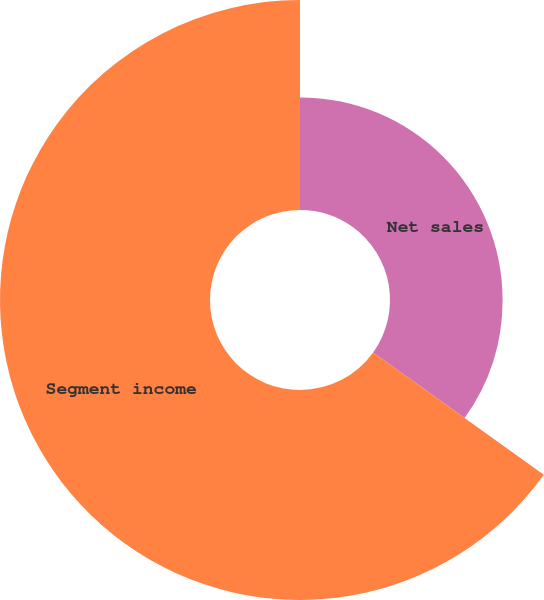<chart> <loc_0><loc_0><loc_500><loc_500><pie_chart><fcel>Net sales<fcel>Segment income<nl><fcel>34.9%<fcel>65.1%<nl></chart> 